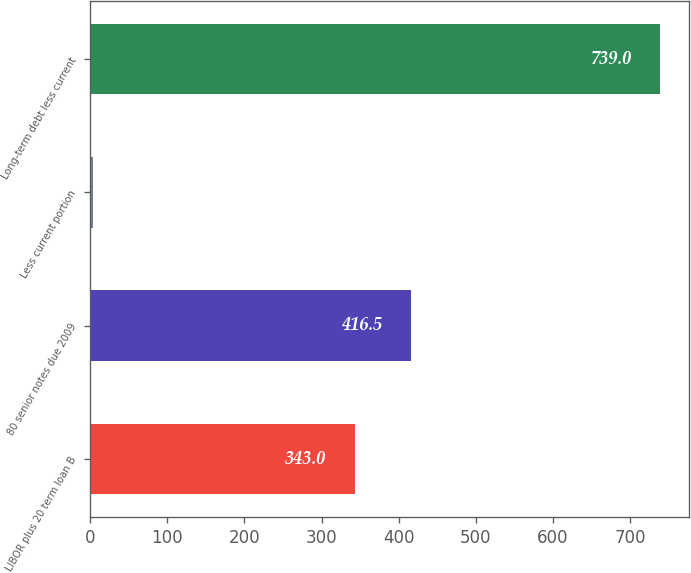Convert chart. <chart><loc_0><loc_0><loc_500><loc_500><bar_chart><fcel>LIBOR plus 20 term loan B<fcel>80 senior notes due 2009<fcel>Less current portion<fcel>Long-term debt less current<nl><fcel>343<fcel>416.5<fcel>4<fcel>739<nl></chart> 